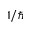<formula> <loc_0><loc_0><loc_500><loc_500>1 / \hbar</formula> 